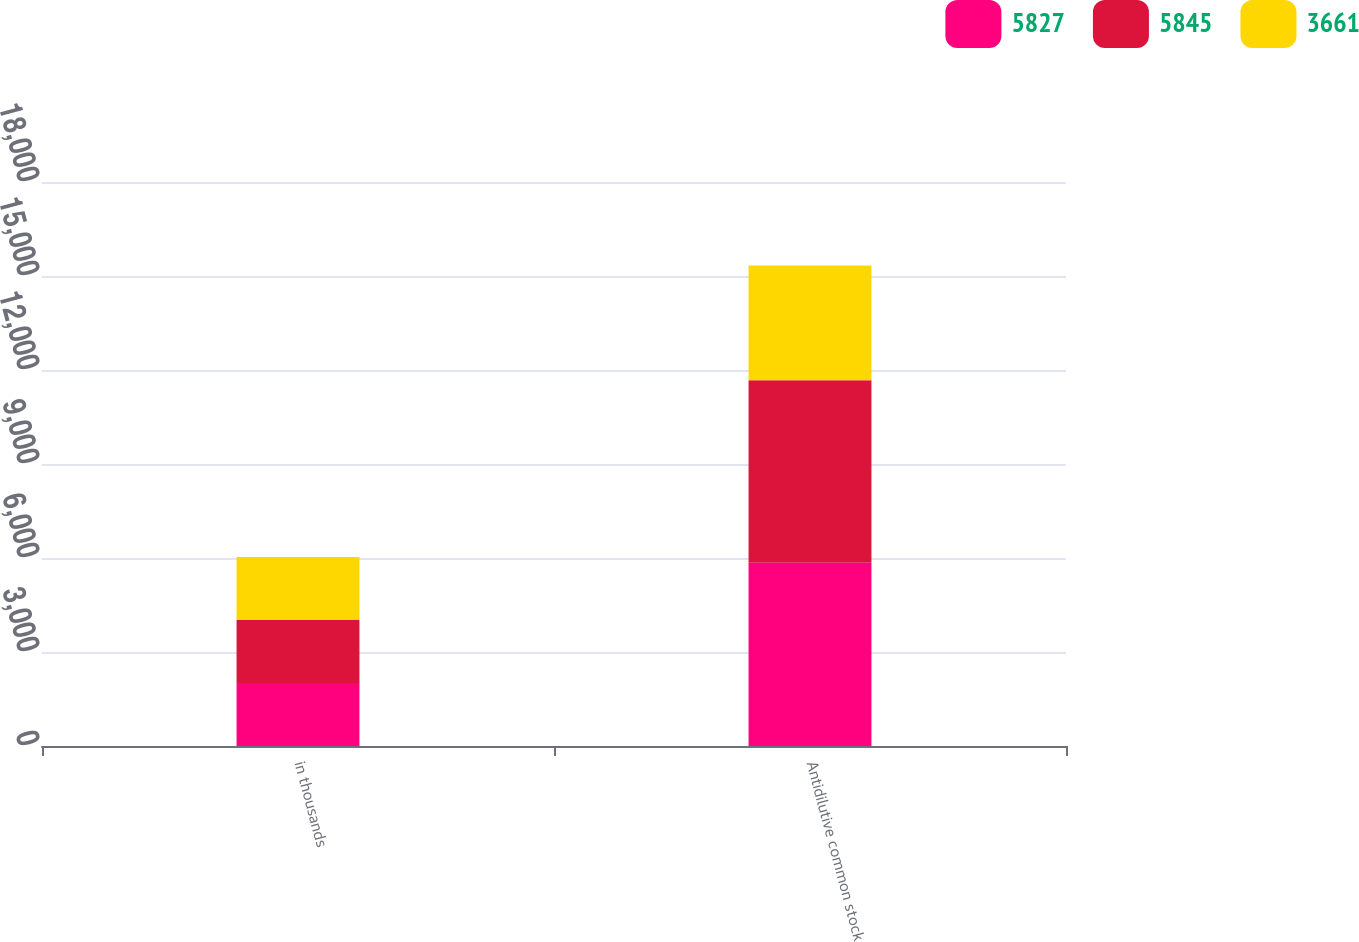<chart> <loc_0><loc_0><loc_500><loc_500><stacked_bar_chart><ecel><fcel>in thousands<fcel>Antidilutive common stock<nl><fcel>5827<fcel>2011<fcel>5845<nl><fcel>5845<fcel>2010<fcel>5827<nl><fcel>3661<fcel>2009<fcel>3661<nl></chart> 